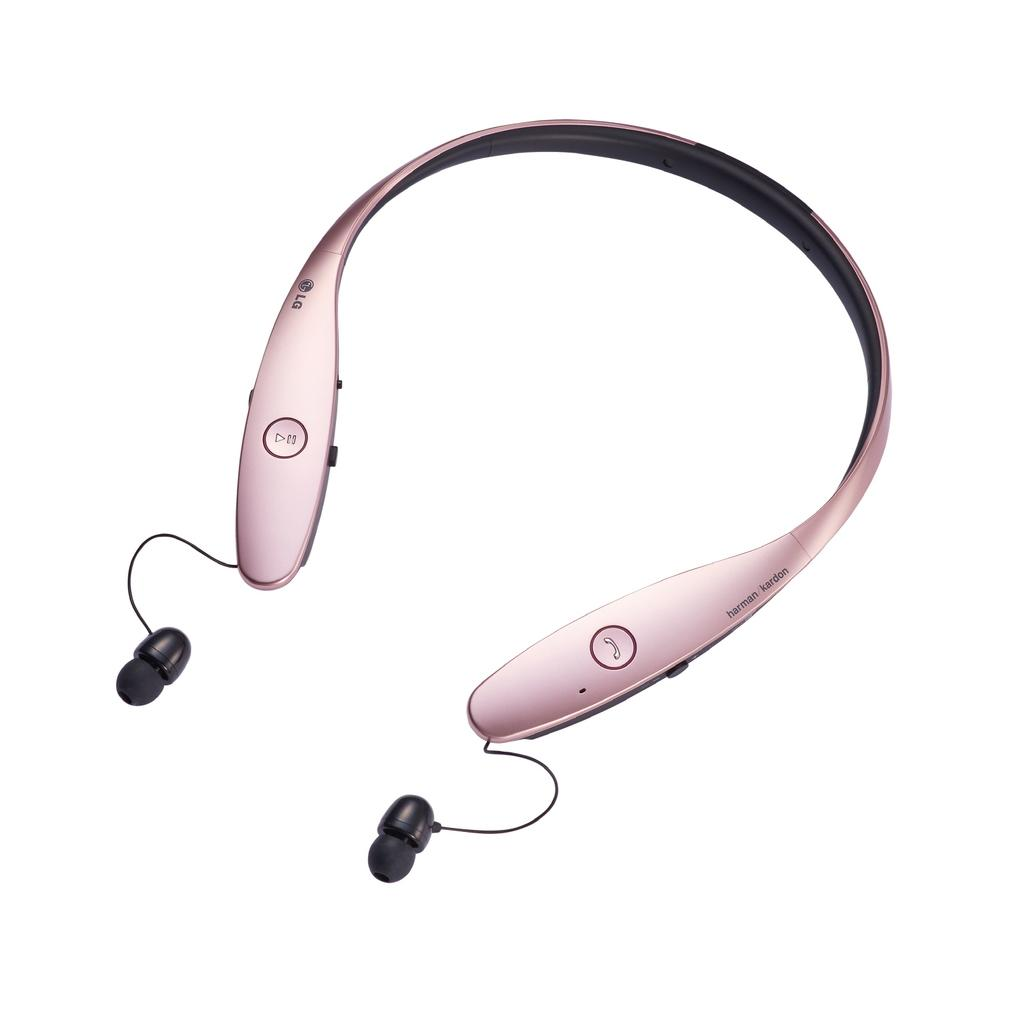What type of electronic device is visible in the image? There is a bluetooth headset in the image. What type of rabbit can be seen wearing the stocking in the mine in the image? There is no rabbit, stocking, or mine present in the image; it only features a bluetooth headset. 